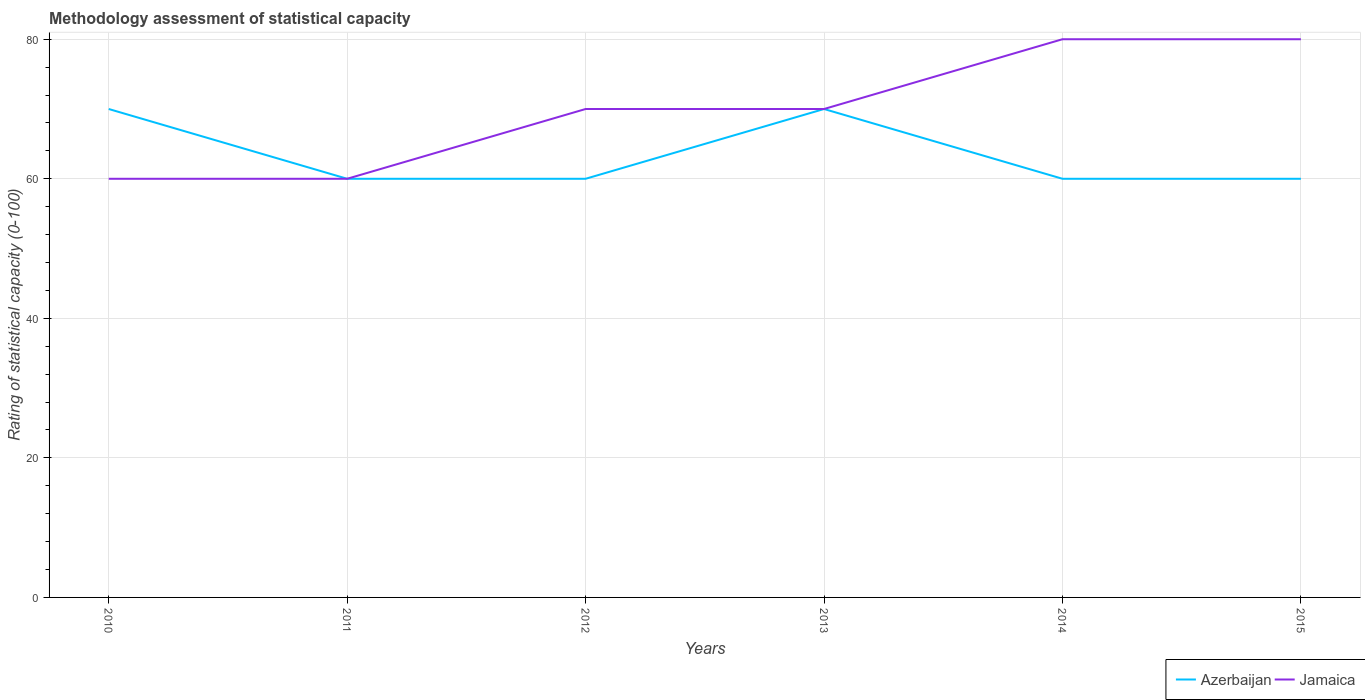Does the line corresponding to Azerbaijan intersect with the line corresponding to Jamaica?
Provide a short and direct response. Yes. Is the number of lines equal to the number of legend labels?
Provide a succinct answer. Yes. Across all years, what is the maximum rating of statistical capacity in Azerbaijan?
Your response must be concise. 60. What is the difference between the highest and the second highest rating of statistical capacity in Jamaica?
Offer a very short reply. 20. What is the difference between the highest and the lowest rating of statistical capacity in Azerbaijan?
Give a very brief answer. 2. How many lines are there?
Provide a short and direct response. 2. How many years are there in the graph?
Keep it short and to the point. 6. Does the graph contain any zero values?
Offer a terse response. No. How many legend labels are there?
Offer a very short reply. 2. What is the title of the graph?
Your answer should be very brief. Methodology assessment of statistical capacity. What is the label or title of the X-axis?
Your response must be concise. Years. What is the label or title of the Y-axis?
Your answer should be very brief. Rating of statistical capacity (0-100). What is the Rating of statistical capacity (0-100) of Azerbaijan in 2010?
Ensure brevity in your answer.  70. What is the Rating of statistical capacity (0-100) of Azerbaijan in 2012?
Your response must be concise. 60. What is the Rating of statistical capacity (0-100) of Jamaica in 2012?
Make the answer very short. 70. What is the Rating of statistical capacity (0-100) of Jamaica in 2013?
Give a very brief answer. 70. Across all years, what is the maximum Rating of statistical capacity (0-100) in Azerbaijan?
Provide a succinct answer. 70. What is the total Rating of statistical capacity (0-100) in Azerbaijan in the graph?
Your answer should be compact. 380. What is the total Rating of statistical capacity (0-100) in Jamaica in the graph?
Keep it short and to the point. 420. What is the difference between the Rating of statistical capacity (0-100) of Azerbaijan in 2010 and that in 2012?
Your answer should be compact. 10. What is the difference between the Rating of statistical capacity (0-100) of Jamaica in 2010 and that in 2012?
Provide a succinct answer. -10. What is the difference between the Rating of statistical capacity (0-100) in Jamaica in 2010 and that in 2015?
Give a very brief answer. -20. What is the difference between the Rating of statistical capacity (0-100) in Jamaica in 2011 and that in 2012?
Provide a short and direct response. -10. What is the difference between the Rating of statistical capacity (0-100) in Azerbaijan in 2011 and that in 2013?
Make the answer very short. -10. What is the difference between the Rating of statistical capacity (0-100) in Jamaica in 2011 and that in 2013?
Keep it short and to the point. -10. What is the difference between the Rating of statistical capacity (0-100) of Azerbaijan in 2011 and that in 2015?
Your answer should be very brief. 0. What is the difference between the Rating of statistical capacity (0-100) in Jamaica in 2011 and that in 2015?
Offer a very short reply. -20. What is the difference between the Rating of statistical capacity (0-100) in Azerbaijan in 2012 and that in 2013?
Keep it short and to the point. -10. What is the difference between the Rating of statistical capacity (0-100) in Jamaica in 2012 and that in 2013?
Offer a very short reply. 0. What is the difference between the Rating of statistical capacity (0-100) of Azerbaijan in 2012 and that in 2015?
Make the answer very short. 0. What is the difference between the Rating of statistical capacity (0-100) of Jamaica in 2012 and that in 2015?
Your answer should be compact. -10. What is the difference between the Rating of statistical capacity (0-100) in Azerbaijan in 2013 and that in 2014?
Make the answer very short. 10. What is the difference between the Rating of statistical capacity (0-100) of Azerbaijan in 2013 and that in 2015?
Provide a succinct answer. 10. What is the difference between the Rating of statistical capacity (0-100) of Jamaica in 2013 and that in 2015?
Your response must be concise. -10. What is the difference between the Rating of statistical capacity (0-100) of Jamaica in 2014 and that in 2015?
Ensure brevity in your answer.  0. What is the difference between the Rating of statistical capacity (0-100) in Azerbaijan in 2010 and the Rating of statistical capacity (0-100) in Jamaica in 2015?
Ensure brevity in your answer.  -10. What is the difference between the Rating of statistical capacity (0-100) in Azerbaijan in 2011 and the Rating of statistical capacity (0-100) in Jamaica in 2013?
Offer a terse response. -10. What is the difference between the Rating of statistical capacity (0-100) of Azerbaijan in 2011 and the Rating of statistical capacity (0-100) of Jamaica in 2014?
Give a very brief answer. -20. What is the difference between the Rating of statistical capacity (0-100) of Azerbaijan in 2011 and the Rating of statistical capacity (0-100) of Jamaica in 2015?
Make the answer very short. -20. What is the difference between the Rating of statistical capacity (0-100) of Azerbaijan in 2013 and the Rating of statistical capacity (0-100) of Jamaica in 2014?
Offer a terse response. -10. What is the difference between the Rating of statistical capacity (0-100) of Azerbaijan in 2013 and the Rating of statistical capacity (0-100) of Jamaica in 2015?
Provide a short and direct response. -10. What is the difference between the Rating of statistical capacity (0-100) in Azerbaijan in 2014 and the Rating of statistical capacity (0-100) in Jamaica in 2015?
Provide a succinct answer. -20. What is the average Rating of statistical capacity (0-100) in Azerbaijan per year?
Give a very brief answer. 63.33. In the year 2012, what is the difference between the Rating of statistical capacity (0-100) of Azerbaijan and Rating of statistical capacity (0-100) of Jamaica?
Offer a terse response. -10. In the year 2013, what is the difference between the Rating of statistical capacity (0-100) in Azerbaijan and Rating of statistical capacity (0-100) in Jamaica?
Your answer should be very brief. 0. In the year 2014, what is the difference between the Rating of statistical capacity (0-100) of Azerbaijan and Rating of statistical capacity (0-100) of Jamaica?
Your answer should be compact. -20. In the year 2015, what is the difference between the Rating of statistical capacity (0-100) of Azerbaijan and Rating of statistical capacity (0-100) of Jamaica?
Provide a short and direct response. -20. What is the ratio of the Rating of statistical capacity (0-100) of Azerbaijan in 2010 to that in 2011?
Provide a succinct answer. 1.17. What is the ratio of the Rating of statistical capacity (0-100) of Jamaica in 2010 to that in 2011?
Keep it short and to the point. 1. What is the ratio of the Rating of statistical capacity (0-100) in Jamaica in 2010 to that in 2012?
Ensure brevity in your answer.  0.86. What is the ratio of the Rating of statistical capacity (0-100) in Azerbaijan in 2010 to that in 2014?
Your answer should be very brief. 1.17. What is the ratio of the Rating of statistical capacity (0-100) in Jamaica in 2010 to that in 2014?
Keep it short and to the point. 0.75. What is the ratio of the Rating of statistical capacity (0-100) in Azerbaijan in 2011 to that in 2012?
Provide a short and direct response. 1. What is the ratio of the Rating of statistical capacity (0-100) of Azerbaijan in 2011 to that in 2013?
Provide a succinct answer. 0.86. What is the ratio of the Rating of statistical capacity (0-100) of Jamaica in 2011 to that in 2013?
Provide a short and direct response. 0.86. What is the ratio of the Rating of statistical capacity (0-100) of Jamaica in 2011 to that in 2014?
Provide a succinct answer. 0.75. What is the ratio of the Rating of statistical capacity (0-100) in Azerbaijan in 2011 to that in 2015?
Your answer should be compact. 1. What is the ratio of the Rating of statistical capacity (0-100) in Jamaica in 2011 to that in 2015?
Your answer should be compact. 0.75. What is the ratio of the Rating of statistical capacity (0-100) of Azerbaijan in 2012 to that in 2013?
Give a very brief answer. 0.86. What is the ratio of the Rating of statistical capacity (0-100) in Azerbaijan in 2012 to that in 2014?
Your answer should be very brief. 1. What is the ratio of the Rating of statistical capacity (0-100) in Jamaica in 2012 to that in 2014?
Keep it short and to the point. 0.88. What is the ratio of the Rating of statistical capacity (0-100) in Azerbaijan in 2014 to that in 2015?
Give a very brief answer. 1. What is the ratio of the Rating of statistical capacity (0-100) in Jamaica in 2014 to that in 2015?
Give a very brief answer. 1. What is the difference between the highest and the second highest Rating of statistical capacity (0-100) of Azerbaijan?
Offer a very short reply. 0. What is the difference between the highest and the second highest Rating of statistical capacity (0-100) of Jamaica?
Your answer should be compact. 0. What is the difference between the highest and the lowest Rating of statistical capacity (0-100) in Jamaica?
Offer a terse response. 20. 